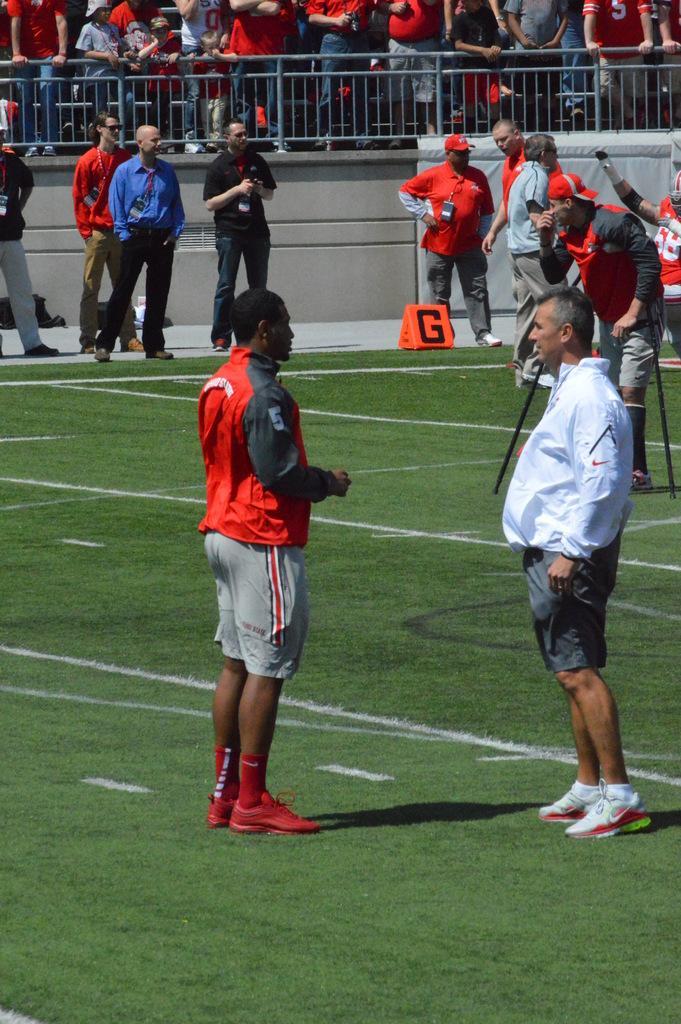How would you summarize this image in a sentence or two? In this image there are so many people standing in the ground behind them there are so many other people standing behind fence and watching at them. 